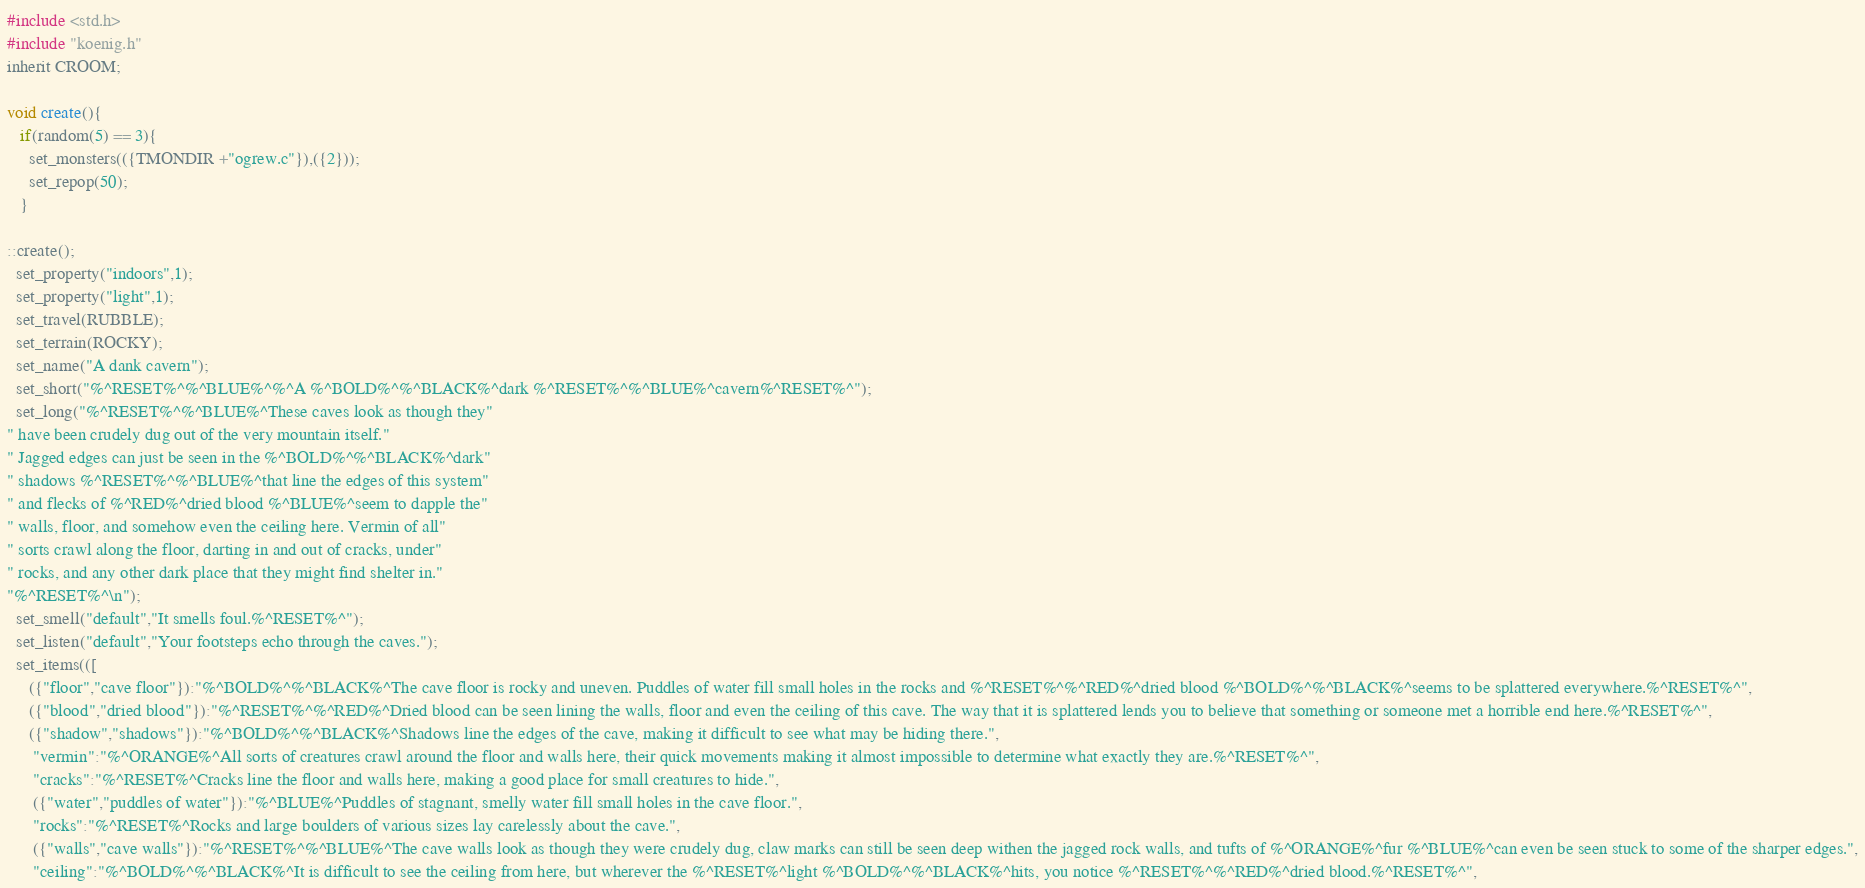Convert code to text. <code><loc_0><loc_0><loc_500><loc_500><_C_>#include <std.h>
#include "koenig.h"
inherit CROOM;

void create(){
   if(random(5) == 3){
     set_monsters(({TMONDIR +"ogrew.c"}),({2}));
     set_repop(50);
   }

::create();
  set_property("indoors",1);
  set_property("light",1);
  set_travel(RUBBLE);
  set_terrain(ROCKY);
  set_name("A dank cavern");
  set_short("%^RESET%^%^BLUE%^%^A %^BOLD%^%^BLACK%^dark %^RESET%^%^BLUE%^cavern%^RESET%^");
  set_long("%^RESET%^%^BLUE%^These caves look as though they"
" have been crudely dug out of the very mountain itself."
" Jagged edges can just be seen in the %^BOLD%^%^BLACK%^dark"
" shadows %^RESET%^%^BLUE%^that line the edges of this system"
" and flecks of %^RED%^dried blood %^BLUE%^seem to dapple the"
" walls, floor, and somehow even the ceiling here. Vermin of all"
" sorts crawl along the floor, darting in and out of cracks, under"
" rocks, and any other dark place that they might find shelter in."
"%^RESET%^\n");
  set_smell("default","It smells foul.%^RESET%^");
  set_listen("default","Your footsteps echo through the caves.");
  set_items(([
     ({"floor","cave floor"}):"%^BOLD%^%^BLACK%^The cave floor is rocky and uneven. Puddles of water fill small holes in the rocks and %^RESET%^%^RED%^dried blood %^BOLD%^%^BLACK%^seems to be splattered everywhere.%^RESET%^",
     ({"blood","dried blood"}):"%^RESET%^%^RED%^Dried blood can be seen lining the walls, floor and even the ceiling of this cave. The way that it is splattered lends you to believe that something or someone met a horrible end here.%^RESET%^",
     ({"shadow","shadows"}):"%^BOLD%^%^BLACK%^Shadows line the edges of the cave, making it difficult to see what may be hiding there.",
      "vermin":"%^ORANGE%^All sorts of creatures crawl around the floor and walls here, their quick movements making it almost impossible to determine what exactly they are.%^RESET%^",
      "cracks":"%^RESET%^Cracks line the floor and walls here, making a good place for small creatures to hide.",
      ({"water","puddles of water"}):"%^BLUE%^Puddles of stagnant, smelly water fill small holes in the cave floor.",
      "rocks":"%^RESET%^Rocks and large boulders of various sizes lay carelessly about the cave.",
      ({"walls","cave walls"}):"%^RESET%^%^BLUE%^The cave walls look as though they were crudely dug, claw marks can still be seen deep withen the jagged rock walls, and tufts of %^ORANGE%^fur %^BLUE%^can even be seen stuck to some of the sharper edges.",
      "ceiling":"%^BOLD%^%^BLACK%^It is difficult to see the ceiling from here, but wherever the %^RESET%^light %^BOLD%^%^BLACK%^hits, you notice %^RESET%^%^RED%^dried blood.%^RESET%^",</code> 